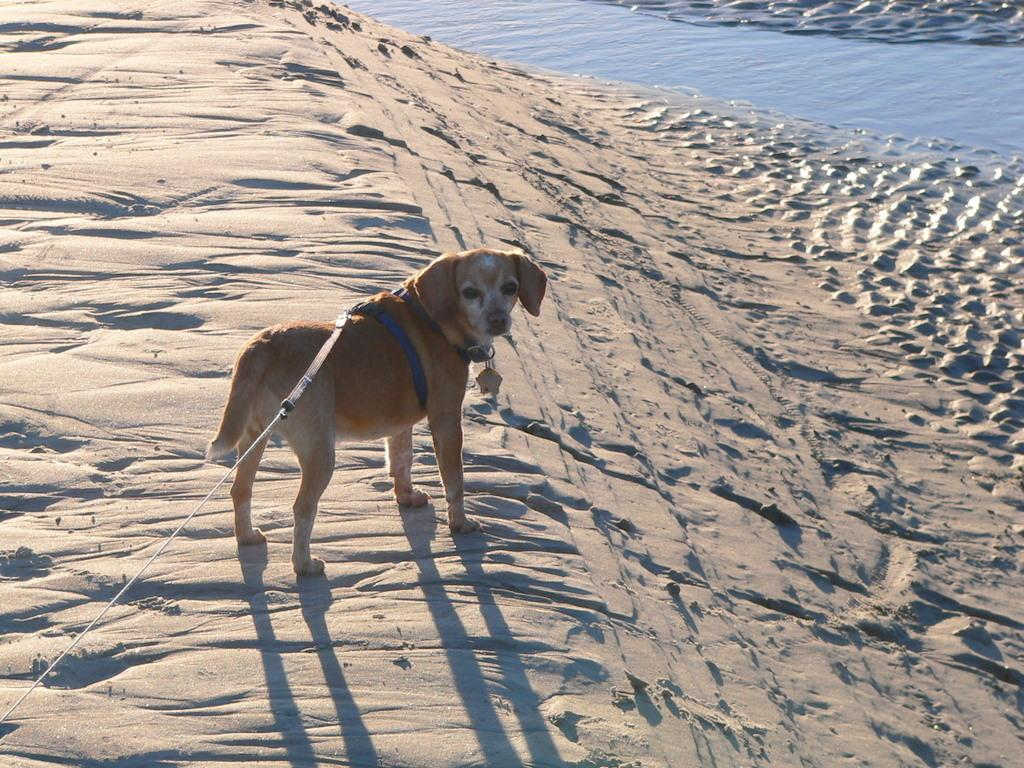What is the main subject in the center of the image? There is a dog in the center of the image. What is the dog doing in the image? The dog is standing. What accessory is on the dog? There is a belt on the dog. What can be seen in the background of the image? There is water visible in the background of the image. What type of terrain is present in the image? There is sand on the ground in the image. What type of plastic is covering the dog's paws in the image? There is no plastic covering the dog's paws in the image. Can you see any popcorn on the ground in the image? There is no popcorn present in the image. 